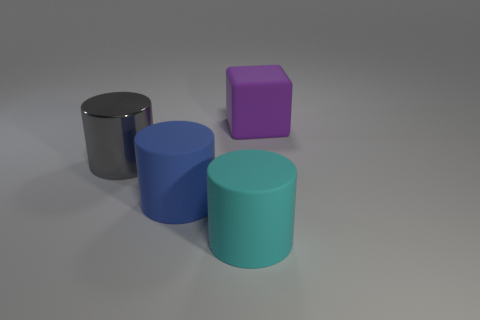Are there any other things that are made of the same material as the big gray cylinder?
Provide a succinct answer. No. Are there any rubber cylinders of the same color as the big matte block?
Your answer should be very brief. No. What is the size of the blue cylinder that is made of the same material as the large cube?
Provide a succinct answer. Large. Are there more large objects that are behind the metal object than purple cubes that are to the right of the purple thing?
Offer a terse response. Yes. How many other objects are the same material as the big block?
Offer a terse response. 2. Do the big object that is left of the blue rubber cylinder and the big blue object have the same material?
Give a very brief answer. No. There is a large cyan object; what shape is it?
Keep it short and to the point. Cylinder. Is the number of big gray metallic objects in front of the large cyan rubber thing greater than the number of large red rubber objects?
Offer a very short reply. No. Is there anything else that has the same shape as the big metallic object?
Your answer should be very brief. Yes. There is another shiny object that is the same shape as the large blue thing; what color is it?
Provide a succinct answer. Gray. 